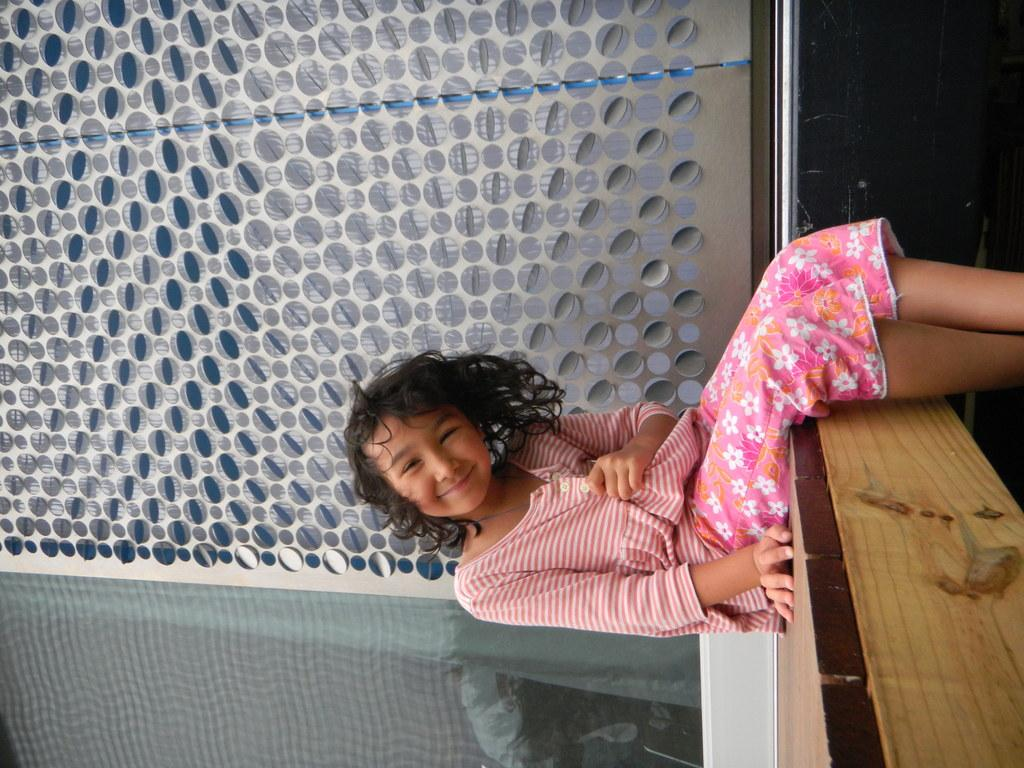Who is the main subject in the image? There is a girl in the image. What is the girl sitting on? The girl is sitting on wooden furniture. What color is the girl's top? The girl is wearing a pink top. What can be seen behind the girl? There is a wall behind the girl. What is special about the wall? The wall has designs on it. What type of apple is being processed by the girl in the image? There is no apple or any indication of a process in the image; it features a girl sitting on wooden furniture and wearing a pink top. 